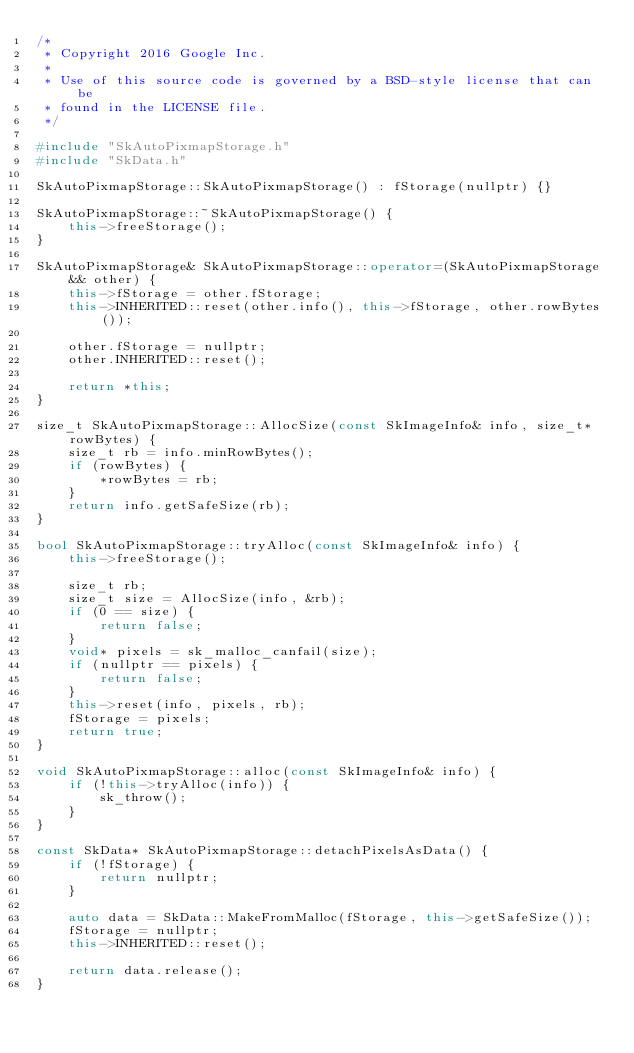Convert code to text. <code><loc_0><loc_0><loc_500><loc_500><_C++_>/*
 * Copyright 2016 Google Inc.
 *
 * Use of this source code is governed by a BSD-style license that can be
 * found in the LICENSE file.
 */

#include "SkAutoPixmapStorage.h"
#include "SkData.h"

SkAutoPixmapStorage::SkAutoPixmapStorage() : fStorage(nullptr) {}

SkAutoPixmapStorage::~SkAutoPixmapStorage() {
    this->freeStorage();
}

SkAutoPixmapStorage& SkAutoPixmapStorage::operator=(SkAutoPixmapStorage&& other) {
    this->fStorage = other.fStorage;
    this->INHERITED::reset(other.info(), this->fStorage, other.rowBytes());

    other.fStorage = nullptr;
    other.INHERITED::reset();

    return *this;
}

size_t SkAutoPixmapStorage::AllocSize(const SkImageInfo& info, size_t* rowBytes) {
    size_t rb = info.minRowBytes();
    if (rowBytes) {
        *rowBytes = rb;
    }
    return info.getSafeSize(rb);
}

bool SkAutoPixmapStorage::tryAlloc(const SkImageInfo& info) {
    this->freeStorage();

    size_t rb;
    size_t size = AllocSize(info, &rb);
    if (0 == size) {
        return false;
    }
    void* pixels = sk_malloc_canfail(size);
    if (nullptr == pixels) {
        return false;
    }
    this->reset(info, pixels, rb);
    fStorage = pixels;
    return true;
}

void SkAutoPixmapStorage::alloc(const SkImageInfo& info) {
    if (!this->tryAlloc(info)) {
        sk_throw();
    }
}

const SkData* SkAutoPixmapStorage::detachPixelsAsData() {
    if (!fStorage) {
        return nullptr;
    }

    auto data = SkData::MakeFromMalloc(fStorage, this->getSafeSize());
    fStorage = nullptr;
    this->INHERITED::reset();

    return data.release();
}
</code> 